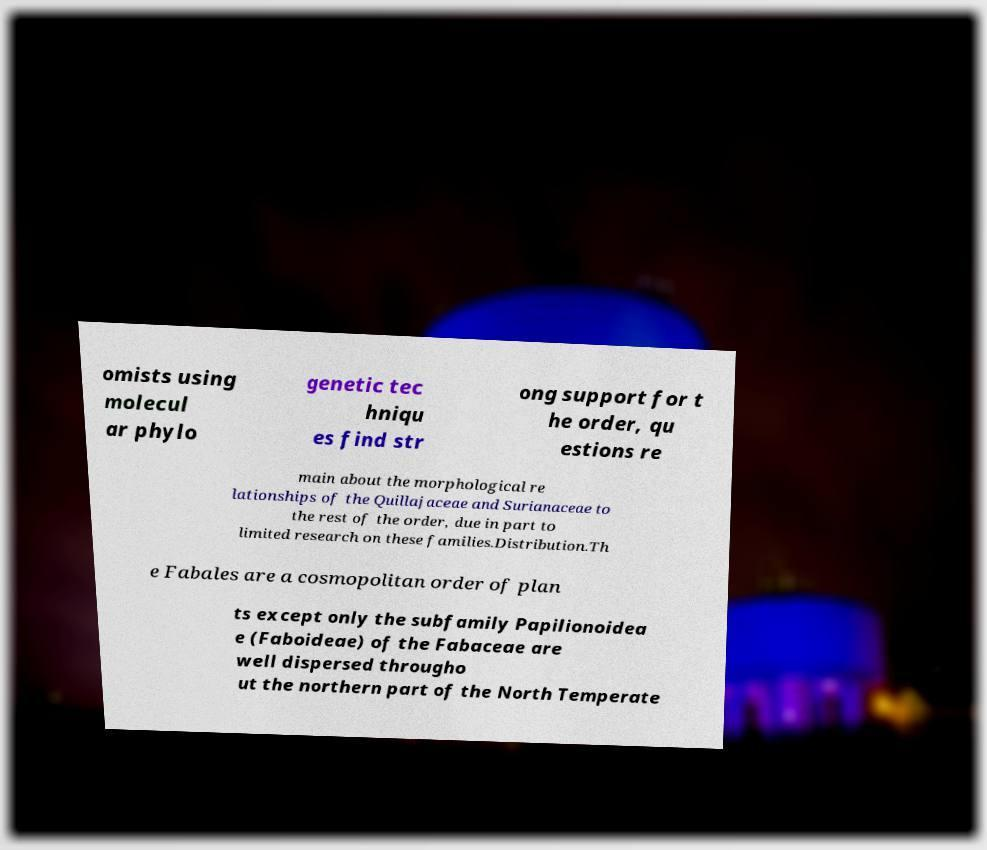For documentation purposes, I need the text within this image transcribed. Could you provide that? omists using molecul ar phylo genetic tec hniqu es find str ong support for t he order, qu estions re main about the morphological re lationships of the Quillajaceae and Surianaceae to the rest of the order, due in part to limited research on these families.Distribution.Th e Fabales are a cosmopolitan order of plan ts except only the subfamily Papilionoidea e (Faboideae) of the Fabaceae are well dispersed througho ut the northern part of the North Temperate 